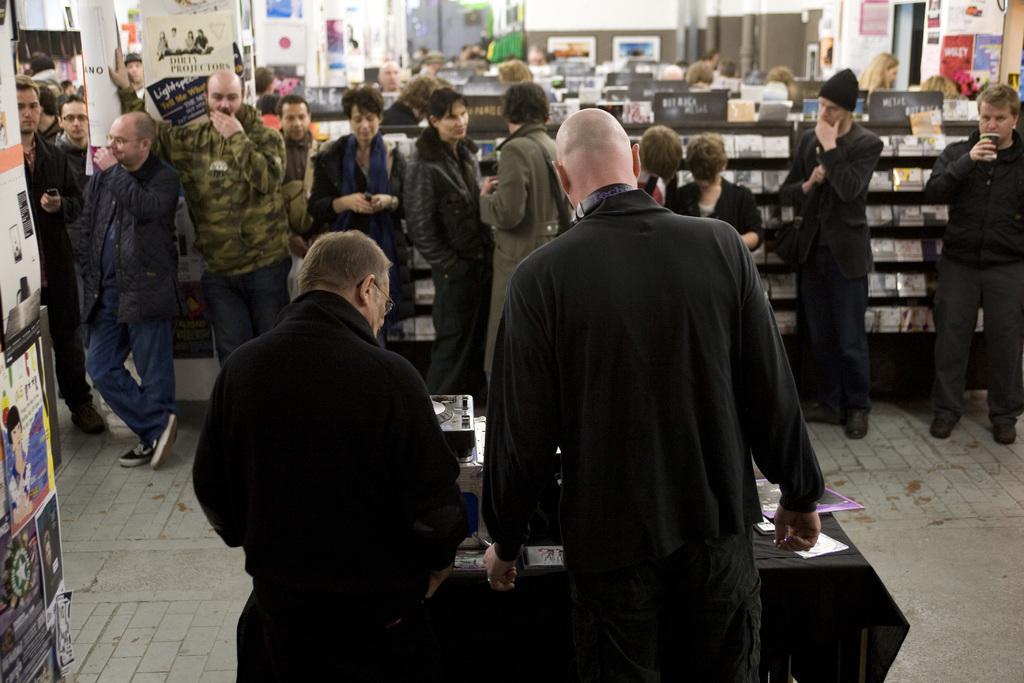Can you describe this image briefly? In this picture all the people are standing. The front two people are standing in front of the table. There are wearing black dress. To the left side there are some posters. 